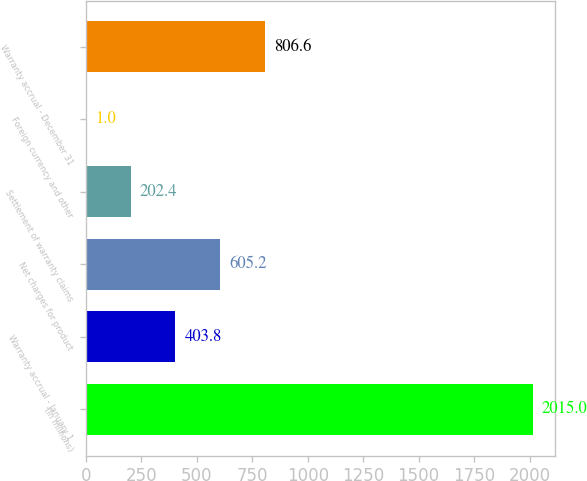Convert chart. <chart><loc_0><loc_0><loc_500><loc_500><bar_chart><fcel>(in millions)<fcel>Warranty accrual - January 1<fcel>Net charges for product<fcel>Settlement of warranty claims<fcel>Foreign currency and other<fcel>Warranty accrual - December 31<nl><fcel>2015<fcel>403.8<fcel>605.2<fcel>202.4<fcel>1<fcel>806.6<nl></chart> 